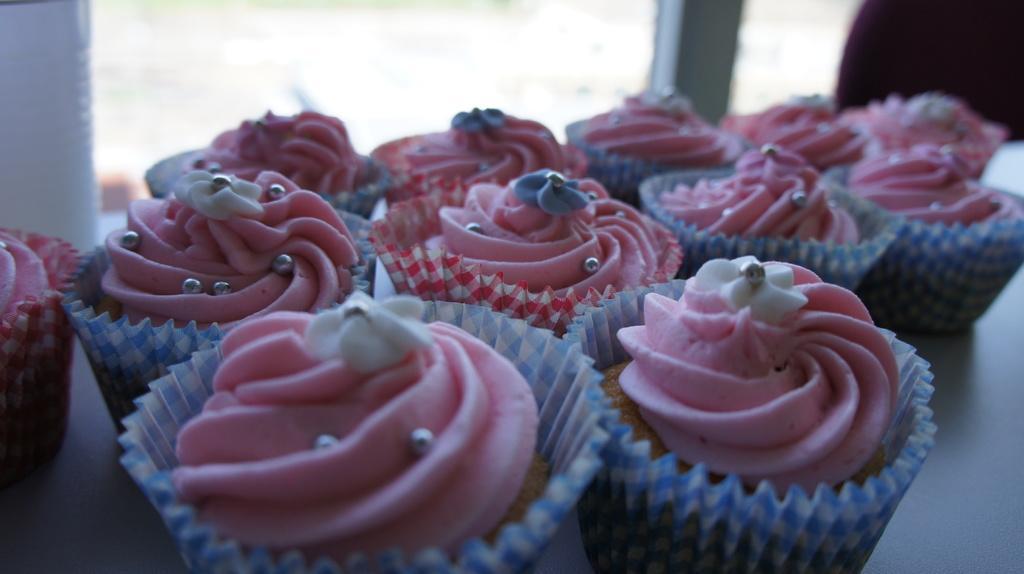Please provide a concise description of this image. In the center of the image we can see cupcakes placed on the table. In the background there is a window. 